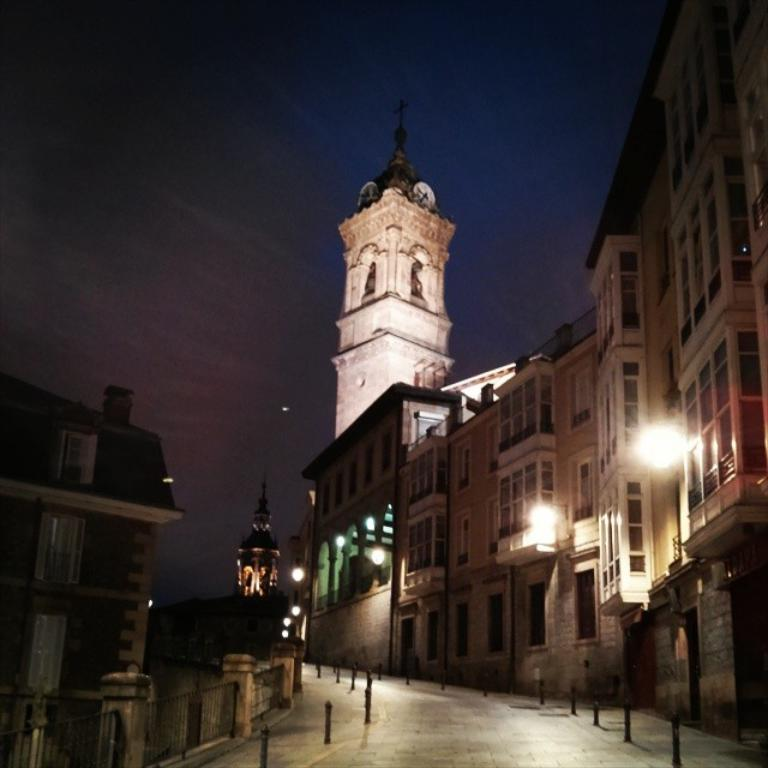What objects can be seen on the road in the image? There are metal poles on the road in the image. What can be seen in the distance behind the road? There are buildings and lights visible in the background of the image. What part of the natural environment is visible in the image? The sky is visible in the background of the image. Can you see the ocean in the background of the image? No, the ocean is not present in the image. What type of button can be seen on the metal poles in the image? There are no buttons visible on the metal poles in the image. 